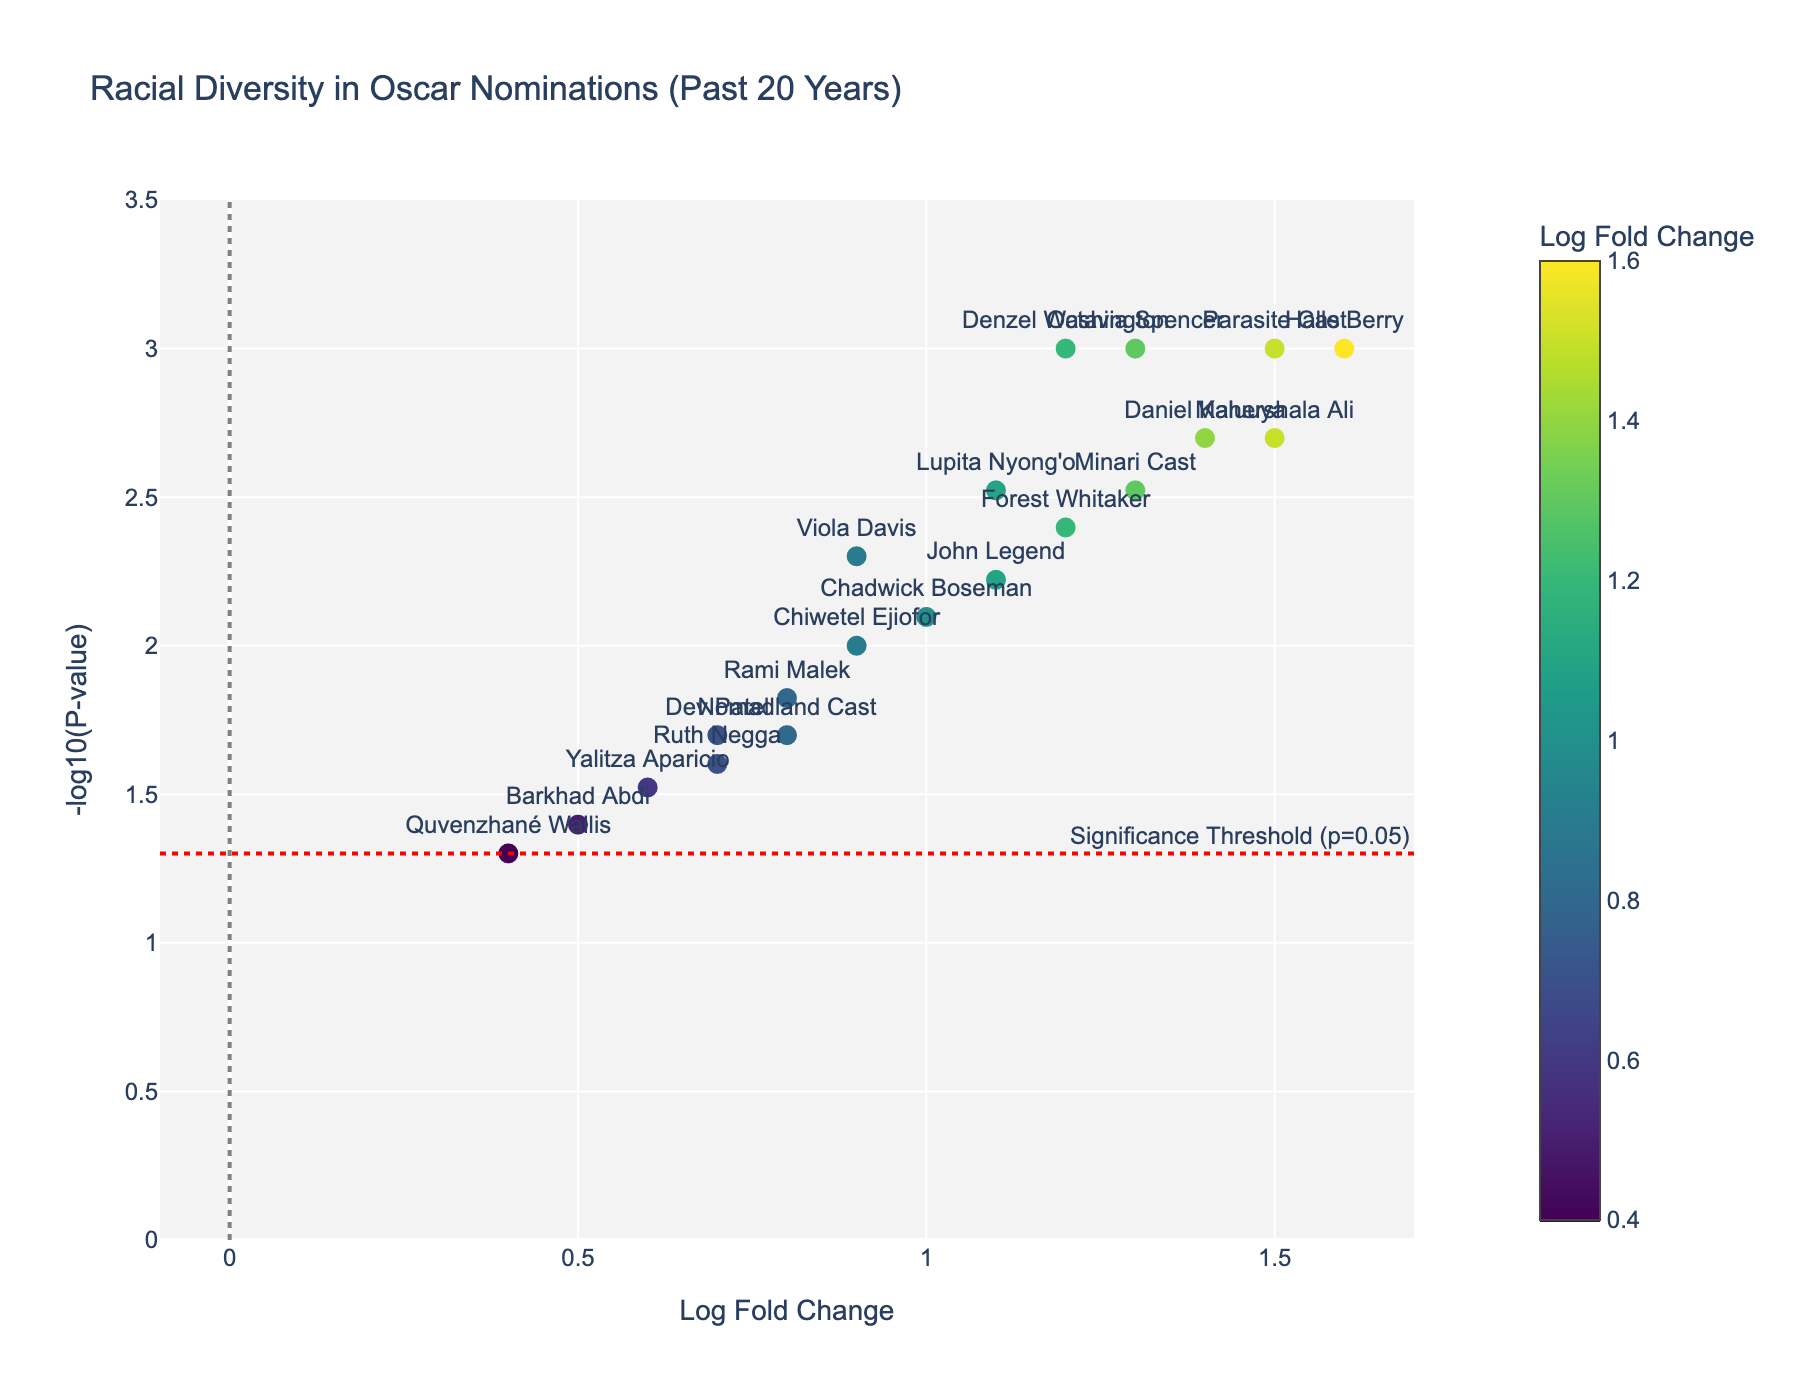What is the title of the plot? The title of the plot can be found at the top of the figure. It summarizes the topic of the visual representation.
Answer: Racial Diversity in Oscar Nominations (Past 20 Years) How many actors have a Log Fold Change higher than 1.0? To answer this, count the data points on the horizontal axis where the "Log Fold Change" is greater than 1.0.
Answer: 10 What color scale is used for the markers in the plot? Look at the color of the markers and any accompanying color bar, which indicates the color scale used to represent the "Log Fold Change".
Answer: Viridis Which actor has the highest Log Fold Change? Identify the data point with the highest value on the horizontal axis (Log Fold Change) and look for the associated actor name.
Answer: Halle Berry How many actors have a P-value below the significance threshold indicated by the red line? Count the data points below the red significance threshold line (y = -log10 (0.05)).
Answer: 14 Which actor's data point is closest to the y-axis (Log Fold Change = 0)? Look for the data point nearest the vertical line (x = 0) and identify the associated actor.
Answer: Yalitza Aparicio What is the Log Fold Change and P-value for the actor Rami Malek? Find "Rami Malek" in the plot's annotation and hovertext to get the numerical values associated with this actor.
Answer: Log Fold Change: 0.8, P-value: 0.015 Which actor has the smallest value for Log Fold Change? Identify the data point with the smallest value on the horizontal axis (Log Fold Change) and find the corresponding actor.
Answer: Quvenzhané Wallis Compare the Log Fold Change of Octavia Spencer and Daniel Kaluuya. Who has the higher value? Check the values of Log Fold Change on the horizontal axis for both "Octavia Spencer" and "Daniel Kaluuya" and compare.
Answer: Daniel Kaluuya What is the range of the y-axis, and what does it represent? Look at the boundaries of the y-axis and determine what it represents based on the plot's title and axis label.
Answer: The range is 0 to approximately 3.5, and it represents the -log10(P-value) 